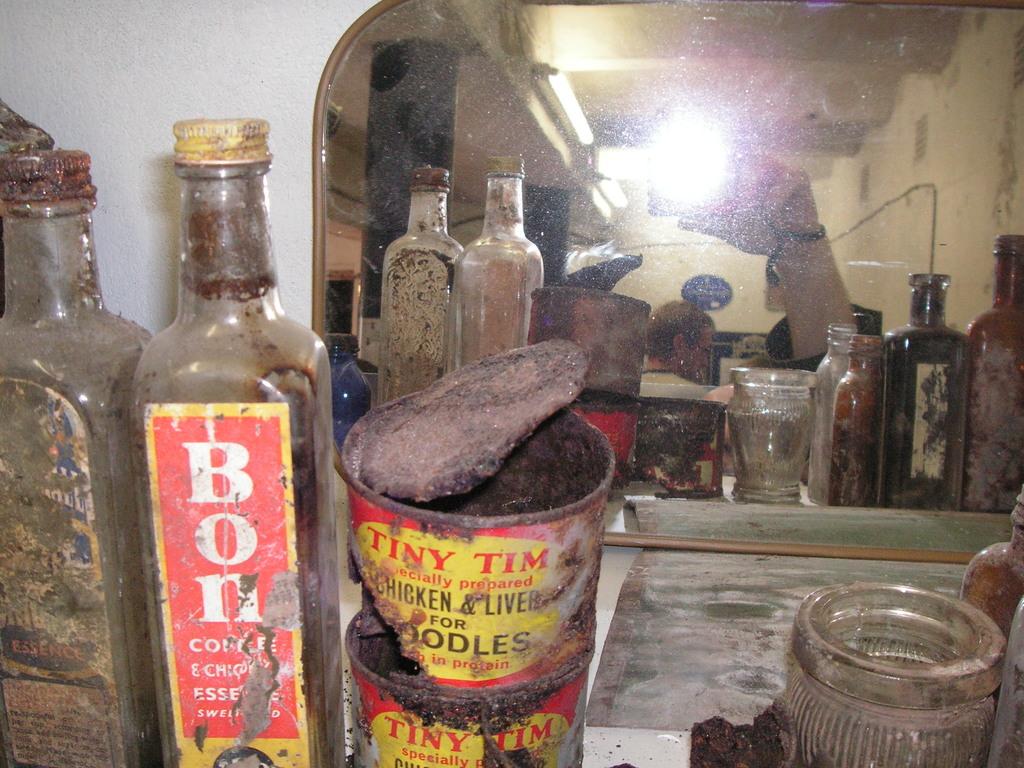What does the bottle say?
Provide a succinct answer. Bon. What beand is the can?
Keep it short and to the point. Tiny tim. 